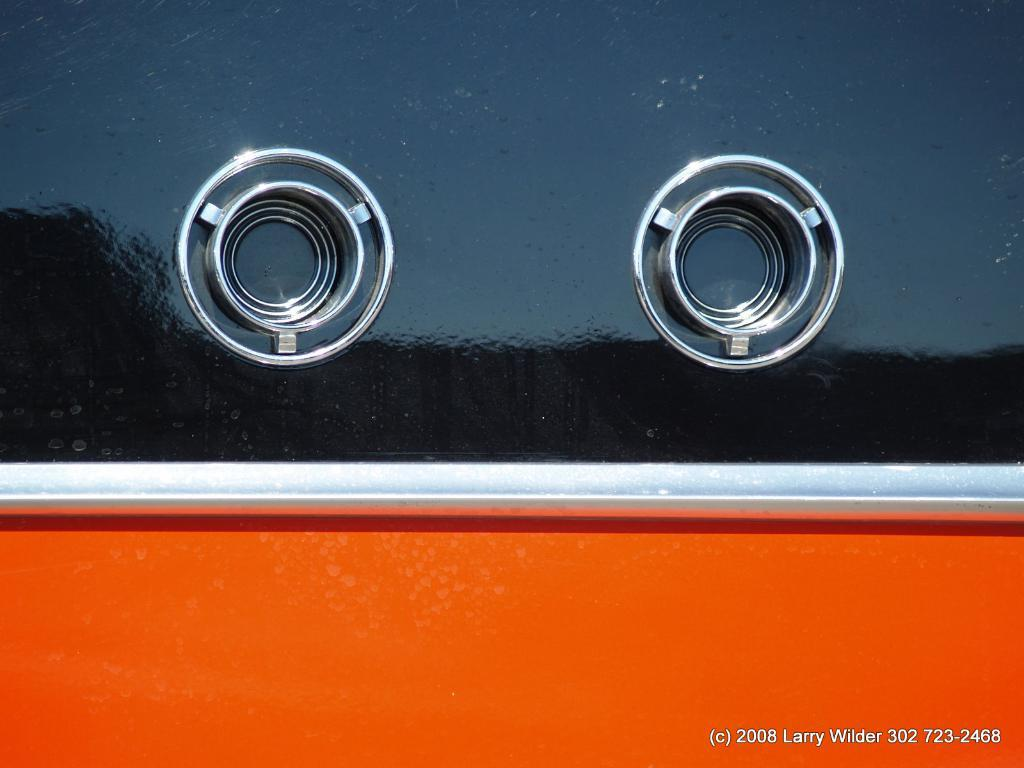What is the main object in the image? There is an object in black and red color in the image, which resembles a car. What are the round objects in the middle of the image? The round objects in the middle of the image look like interior door panels. What type of sound can be heard coming from the car in the image? There is no sound present in the image, as it is a still image and not a video or audio recording. 